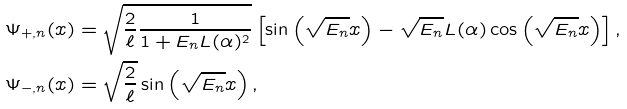<formula> <loc_0><loc_0><loc_500><loc_500>\Psi _ { + , n } ( x ) & = \sqrt { \frac { 2 } { \ell } \frac { 1 } { 1 + E _ { n } L ( \alpha ) ^ { 2 } } } \left [ \sin \left ( \sqrt { E _ { n } } x \right ) - \sqrt { E _ { n } } L ( \alpha ) \cos \left ( \sqrt { E _ { n } } x \right ) \right ] , \\ \Psi _ { - , n } ( x ) & = \sqrt { \frac { 2 } { \ell } } \sin \left ( \sqrt { E _ { n } } x \right ) ,</formula> 